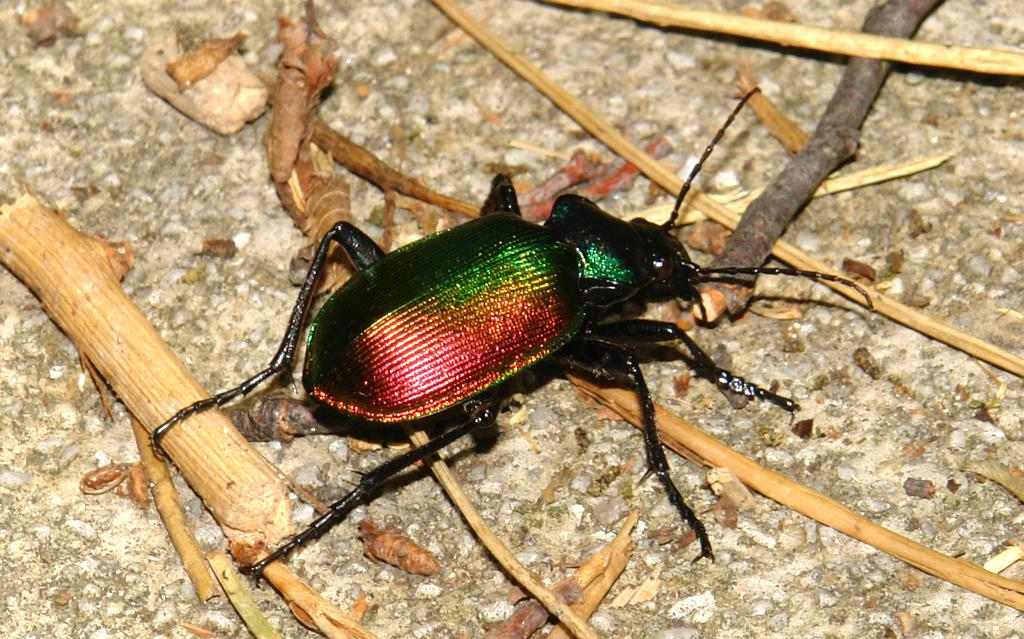What type of insect is in the image? There is a beetle in the image. Where is the beetle located? The beetle is on the ground. What else can be seen in the image besides the beetle? There are a few sticks in the image. How much debt does the beetle owe in the image? There is no mention of debt in the image, and the beetle is not capable of owing debt. 